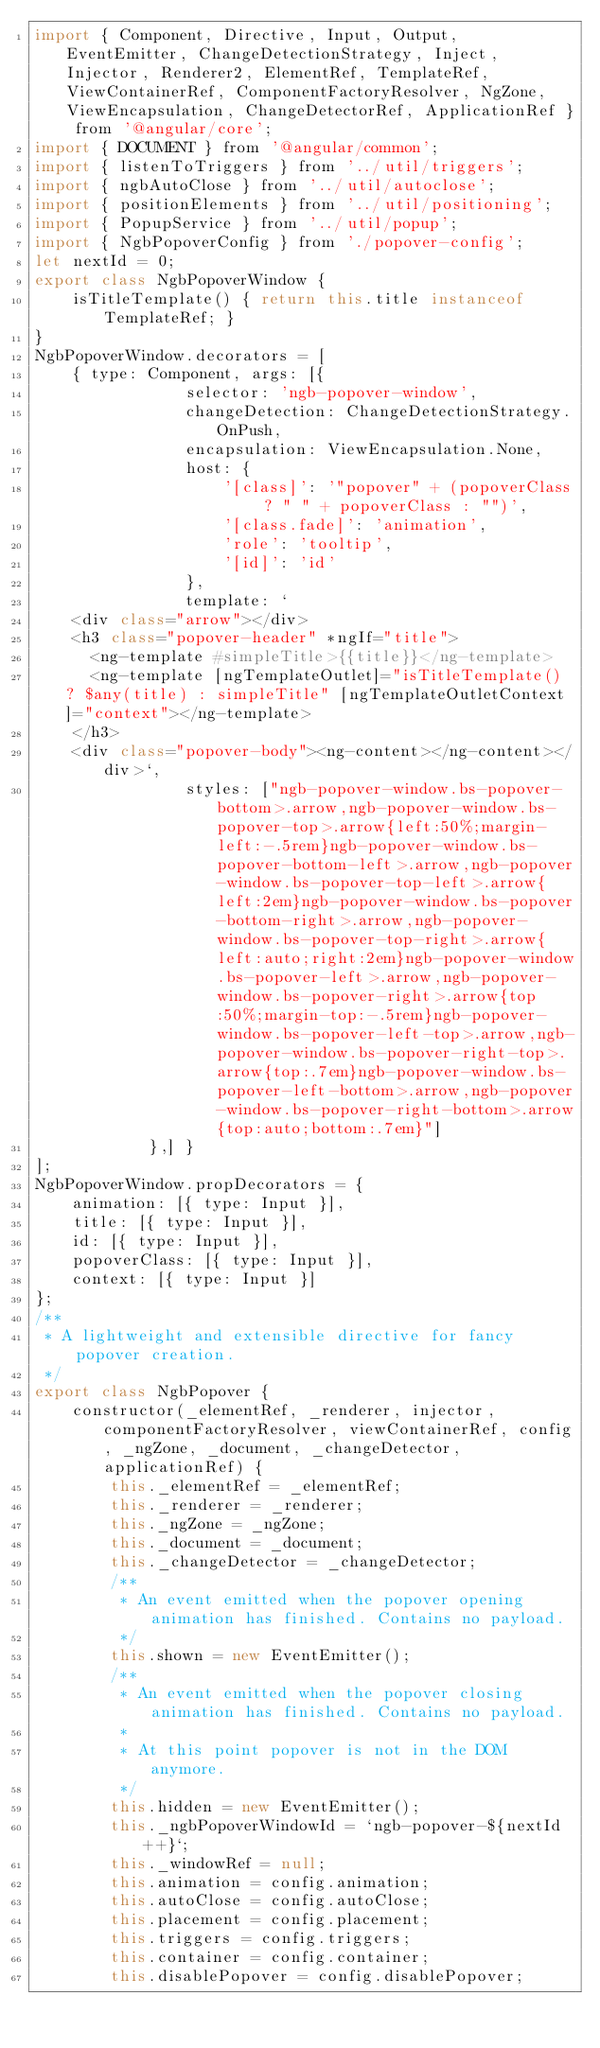<code> <loc_0><loc_0><loc_500><loc_500><_JavaScript_>import { Component, Directive, Input, Output, EventEmitter, ChangeDetectionStrategy, Inject, Injector, Renderer2, ElementRef, TemplateRef, ViewContainerRef, ComponentFactoryResolver, NgZone, ViewEncapsulation, ChangeDetectorRef, ApplicationRef } from '@angular/core';
import { DOCUMENT } from '@angular/common';
import { listenToTriggers } from '../util/triggers';
import { ngbAutoClose } from '../util/autoclose';
import { positionElements } from '../util/positioning';
import { PopupService } from '../util/popup';
import { NgbPopoverConfig } from './popover-config';
let nextId = 0;
export class NgbPopoverWindow {
    isTitleTemplate() { return this.title instanceof TemplateRef; }
}
NgbPopoverWindow.decorators = [
    { type: Component, args: [{
                selector: 'ngb-popover-window',
                changeDetection: ChangeDetectionStrategy.OnPush,
                encapsulation: ViewEncapsulation.None,
                host: {
                    '[class]': '"popover" + (popoverClass ? " " + popoverClass : "")',
                    '[class.fade]': 'animation',
                    'role': 'tooltip',
                    '[id]': 'id'
                },
                template: `
    <div class="arrow"></div>
    <h3 class="popover-header" *ngIf="title">
      <ng-template #simpleTitle>{{title}}</ng-template>
      <ng-template [ngTemplateOutlet]="isTitleTemplate() ? $any(title) : simpleTitle" [ngTemplateOutletContext]="context"></ng-template>
    </h3>
    <div class="popover-body"><ng-content></ng-content></div>`,
                styles: ["ngb-popover-window.bs-popover-bottom>.arrow,ngb-popover-window.bs-popover-top>.arrow{left:50%;margin-left:-.5rem}ngb-popover-window.bs-popover-bottom-left>.arrow,ngb-popover-window.bs-popover-top-left>.arrow{left:2em}ngb-popover-window.bs-popover-bottom-right>.arrow,ngb-popover-window.bs-popover-top-right>.arrow{left:auto;right:2em}ngb-popover-window.bs-popover-left>.arrow,ngb-popover-window.bs-popover-right>.arrow{top:50%;margin-top:-.5rem}ngb-popover-window.bs-popover-left-top>.arrow,ngb-popover-window.bs-popover-right-top>.arrow{top:.7em}ngb-popover-window.bs-popover-left-bottom>.arrow,ngb-popover-window.bs-popover-right-bottom>.arrow{top:auto;bottom:.7em}"]
            },] }
];
NgbPopoverWindow.propDecorators = {
    animation: [{ type: Input }],
    title: [{ type: Input }],
    id: [{ type: Input }],
    popoverClass: [{ type: Input }],
    context: [{ type: Input }]
};
/**
 * A lightweight and extensible directive for fancy popover creation.
 */
export class NgbPopover {
    constructor(_elementRef, _renderer, injector, componentFactoryResolver, viewContainerRef, config, _ngZone, _document, _changeDetector, applicationRef) {
        this._elementRef = _elementRef;
        this._renderer = _renderer;
        this._ngZone = _ngZone;
        this._document = _document;
        this._changeDetector = _changeDetector;
        /**
         * An event emitted when the popover opening animation has finished. Contains no payload.
         */
        this.shown = new EventEmitter();
        /**
         * An event emitted when the popover closing animation has finished. Contains no payload.
         *
         * At this point popover is not in the DOM anymore.
         */
        this.hidden = new EventEmitter();
        this._ngbPopoverWindowId = `ngb-popover-${nextId++}`;
        this._windowRef = null;
        this.animation = config.animation;
        this.autoClose = config.autoClose;
        this.placement = config.placement;
        this.triggers = config.triggers;
        this.container = config.container;
        this.disablePopover = config.disablePopover;</code> 